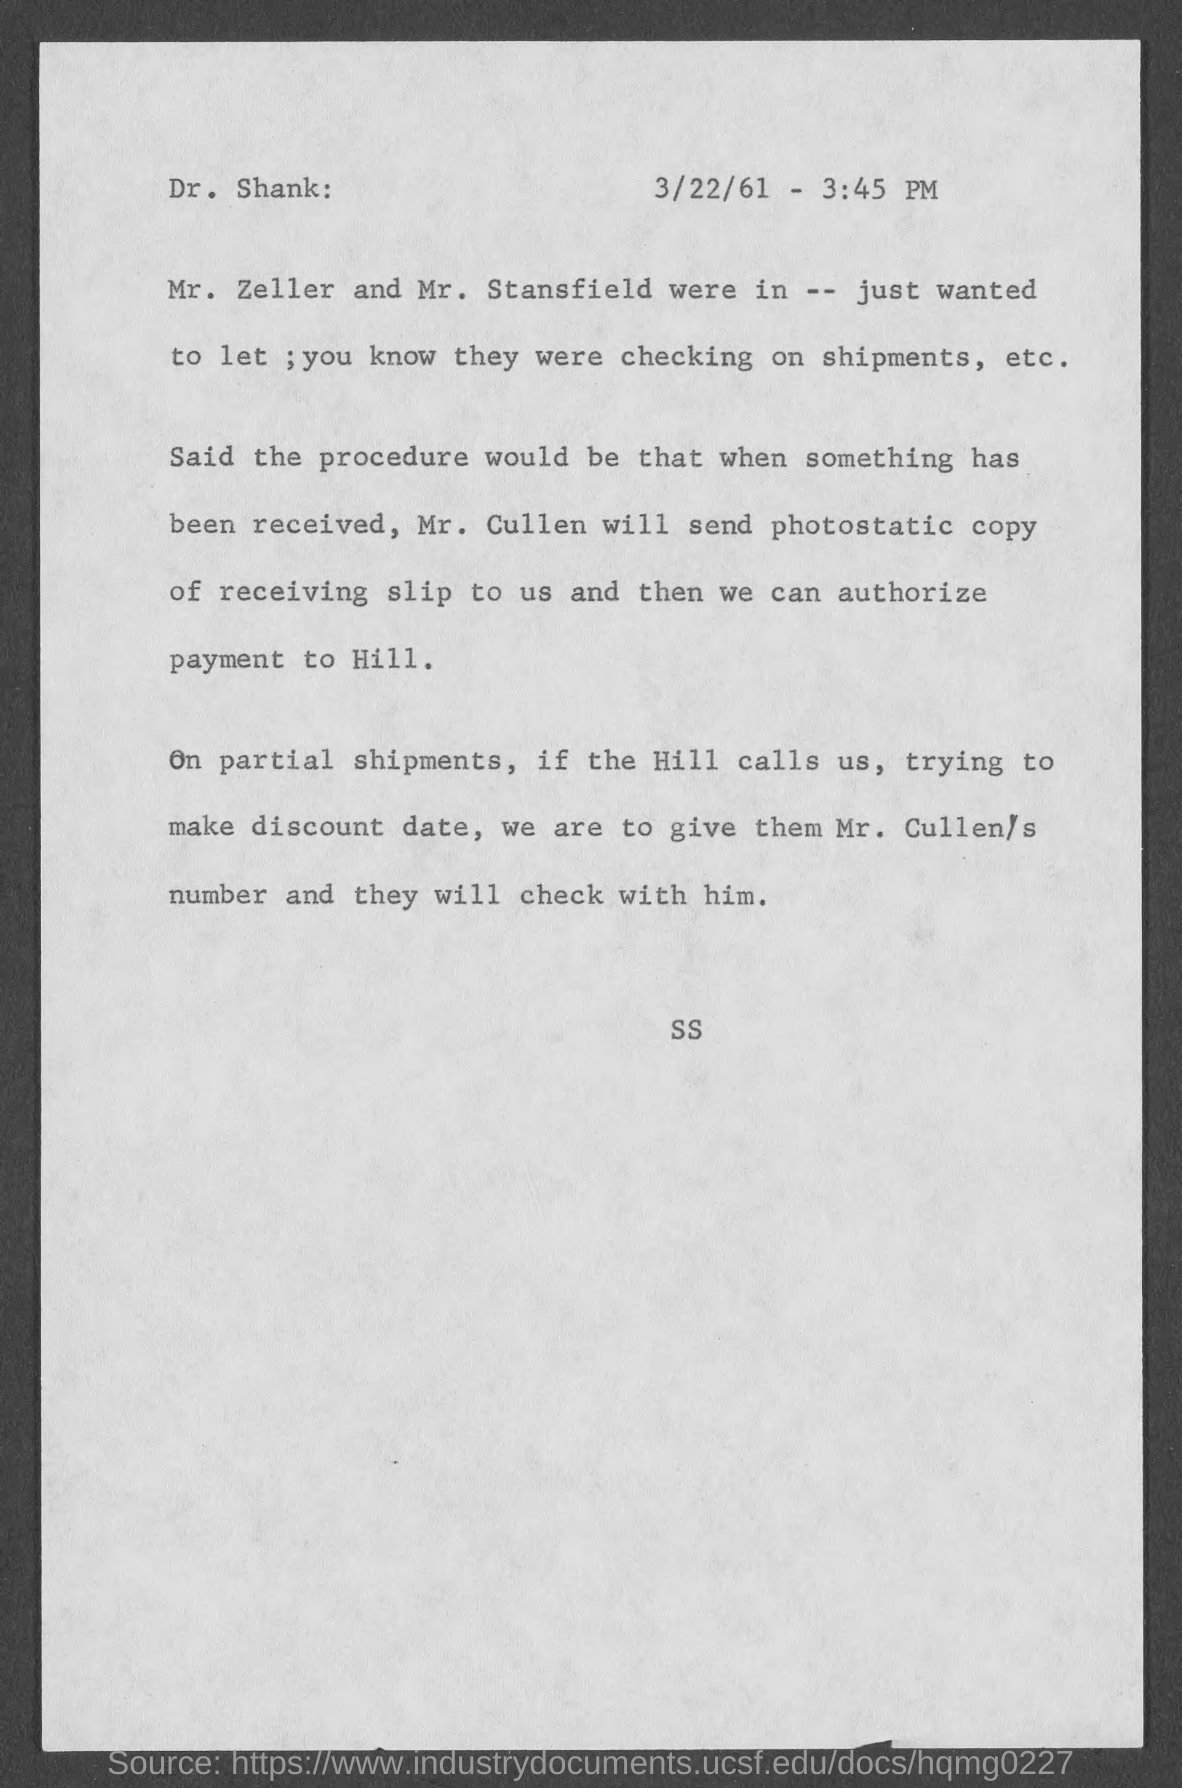Specify some key components in this picture. It is 3:45 pm. It is necessary for Mr. Cullen to obtain a photostatic copy of the receiving slip. The document is dated March 22, 1961. 